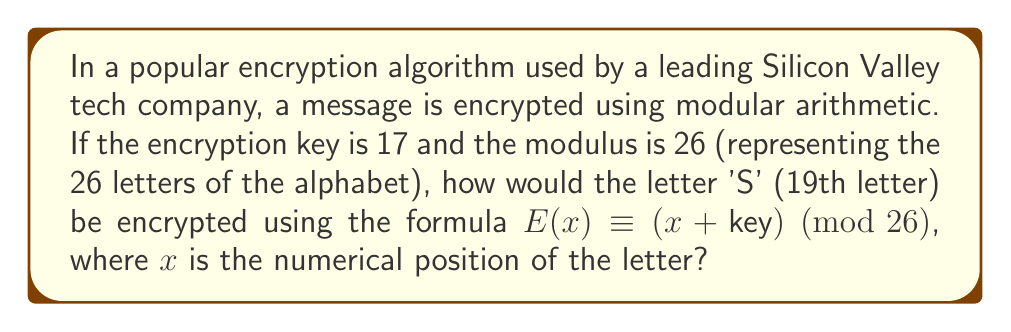Can you solve this math problem? To solve this problem, we need to apply the principles of modular arithmetic, which is fundamental to many cryptographic algorithms. Let's break it down step-by-step:

1) First, we identify the given information:
   - The letter to encrypt is 'S'
   - 'S' is the 19th letter of the alphabet, so $x = 19$
   - The encryption key is 17
   - The modulus is 26 (representing the 26 letters of the alphabet)

2) We'll use the encryption formula: $E(x) \equiv (x + key) \pmod{26}$

3) Let's substitute our values into the formula:
   $E(19) \equiv (19 + 17) \pmod{26}$

4) Simplify the addition inside the parentheses:
   $E(19) \equiv 36 \pmod{26}$

5) Now, we need to find the remainder when 36 is divided by 26:
   $36 \div 26 = 1$ remainder $10$

6) Therefore, $36 \equiv 10 \pmod{26}$

7) This means that the encrypted value is 10, which corresponds to the 10th letter of the alphabet.

8) The 10th letter of the alphabet is 'J'

This process demonstrates how modular arithmetic is used in cryptography to transform plaintext into ciphertext, a crucial aspect of secure communication in the digital age.
Answer: The letter 'S' would be encrypted as 'J'. 